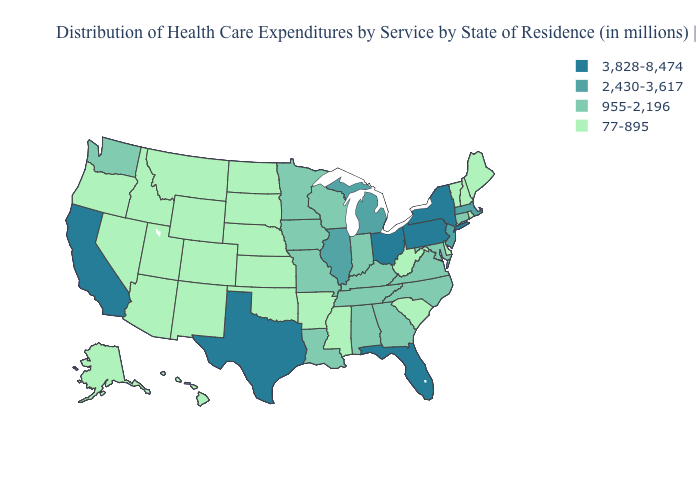Is the legend a continuous bar?
Concise answer only. No. What is the value of Kansas?
Quick response, please. 77-895. Name the states that have a value in the range 2,430-3,617?
Give a very brief answer. Illinois, Massachusetts, Michigan, New Jersey. What is the value of Wisconsin?
Quick response, please. 955-2,196. Does New York have the lowest value in the Northeast?
Short answer required. No. Name the states that have a value in the range 77-895?
Keep it brief. Alaska, Arizona, Arkansas, Colorado, Delaware, Hawaii, Idaho, Kansas, Maine, Mississippi, Montana, Nebraska, Nevada, New Hampshire, New Mexico, North Dakota, Oklahoma, Oregon, Rhode Island, South Carolina, South Dakota, Utah, Vermont, West Virginia, Wyoming. What is the lowest value in states that border Kansas?
Be succinct. 77-895. Does the first symbol in the legend represent the smallest category?
Answer briefly. No. Name the states that have a value in the range 77-895?
Be succinct. Alaska, Arizona, Arkansas, Colorado, Delaware, Hawaii, Idaho, Kansas, Maine, Mississippi, Montana, Nebraska, Nevada, New Hampshire, New Mexico, North Dakota, Oklahoma, Oregon, Rhode Island, South Carolina, South Dakota, Utah, Vermont, West Virginia, Wyoming. Which states have the lowest value in the MidWest?
Concise answer only. Kansas, Nebraska, North Dakota, South Dakota. Name the states that have a value in the range 3,828-8,474?
Write a very short answer. California, Florida, New York, Ohio, Pennsylvania, Texas. Which states have the lowest value in the USA?
Give a very brief answer. Alaska, Arizona, Arkansas, Colorado, Delaware, Hawaii, Idaho, Kansas, Maine, Mississippi, Montana, Nebraska, Nevada, New Hampshire, New Mexico, North Dakota, Oklahoma, Oregon, Rhode Island, South Carolina, South Dakota, Utah, Vermont, West Virginia, Wyoming. Does West Virginia have the lowest value in the USA?
Give a very brief answer. Yes. Name the states that have a value in the range 77-895?
Quick response, please. Alaska, Arizona, Arkansas, Colorado, Delaware, Hawaii, Idaho, Kansas, Maine, Mississippi, Montana, Nebraska, Nevada, New Hampshire, New Mexico, North Dakota, Oklahoma, Oregon, Rhode Island, South Carolina, South Dakota, Utah, Vermont, West Virginia, Wyoming. 